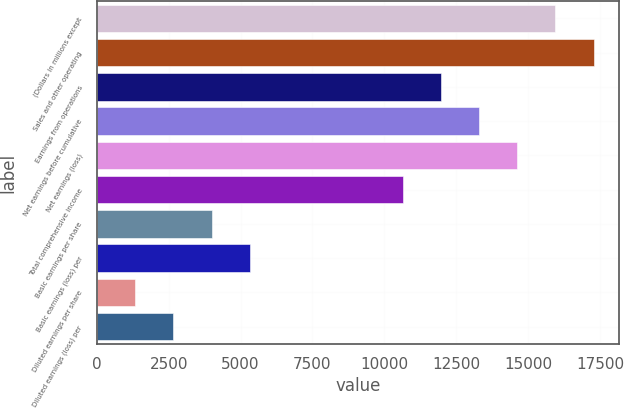Convert chart to OTSL. <chart><loc_0><loc_0><loc_500><loc_500><bar_chart><fcel>(Dollars in millions except<fcel>Sales and other operating<fcel>Earnings from operations<fcel>Net earnings before cumulative<fcel>Net earnings (loss)<fcel>Total comprehensive income<fcel>Basic earnings per share<fcel>Basic earnings (loss) per<fcel>Diluted earnings per share<fcel>Diluted earnings (loss) per<nl><fcel>15951.5<fcel>17280.8<fcel>11963.7<fcel>13293<fcel>14622.2<fcel>10634.4<fcel>3988.01<fcel>5317.29<fcel>1329.45<fcel>2658.73<nl></chart> 